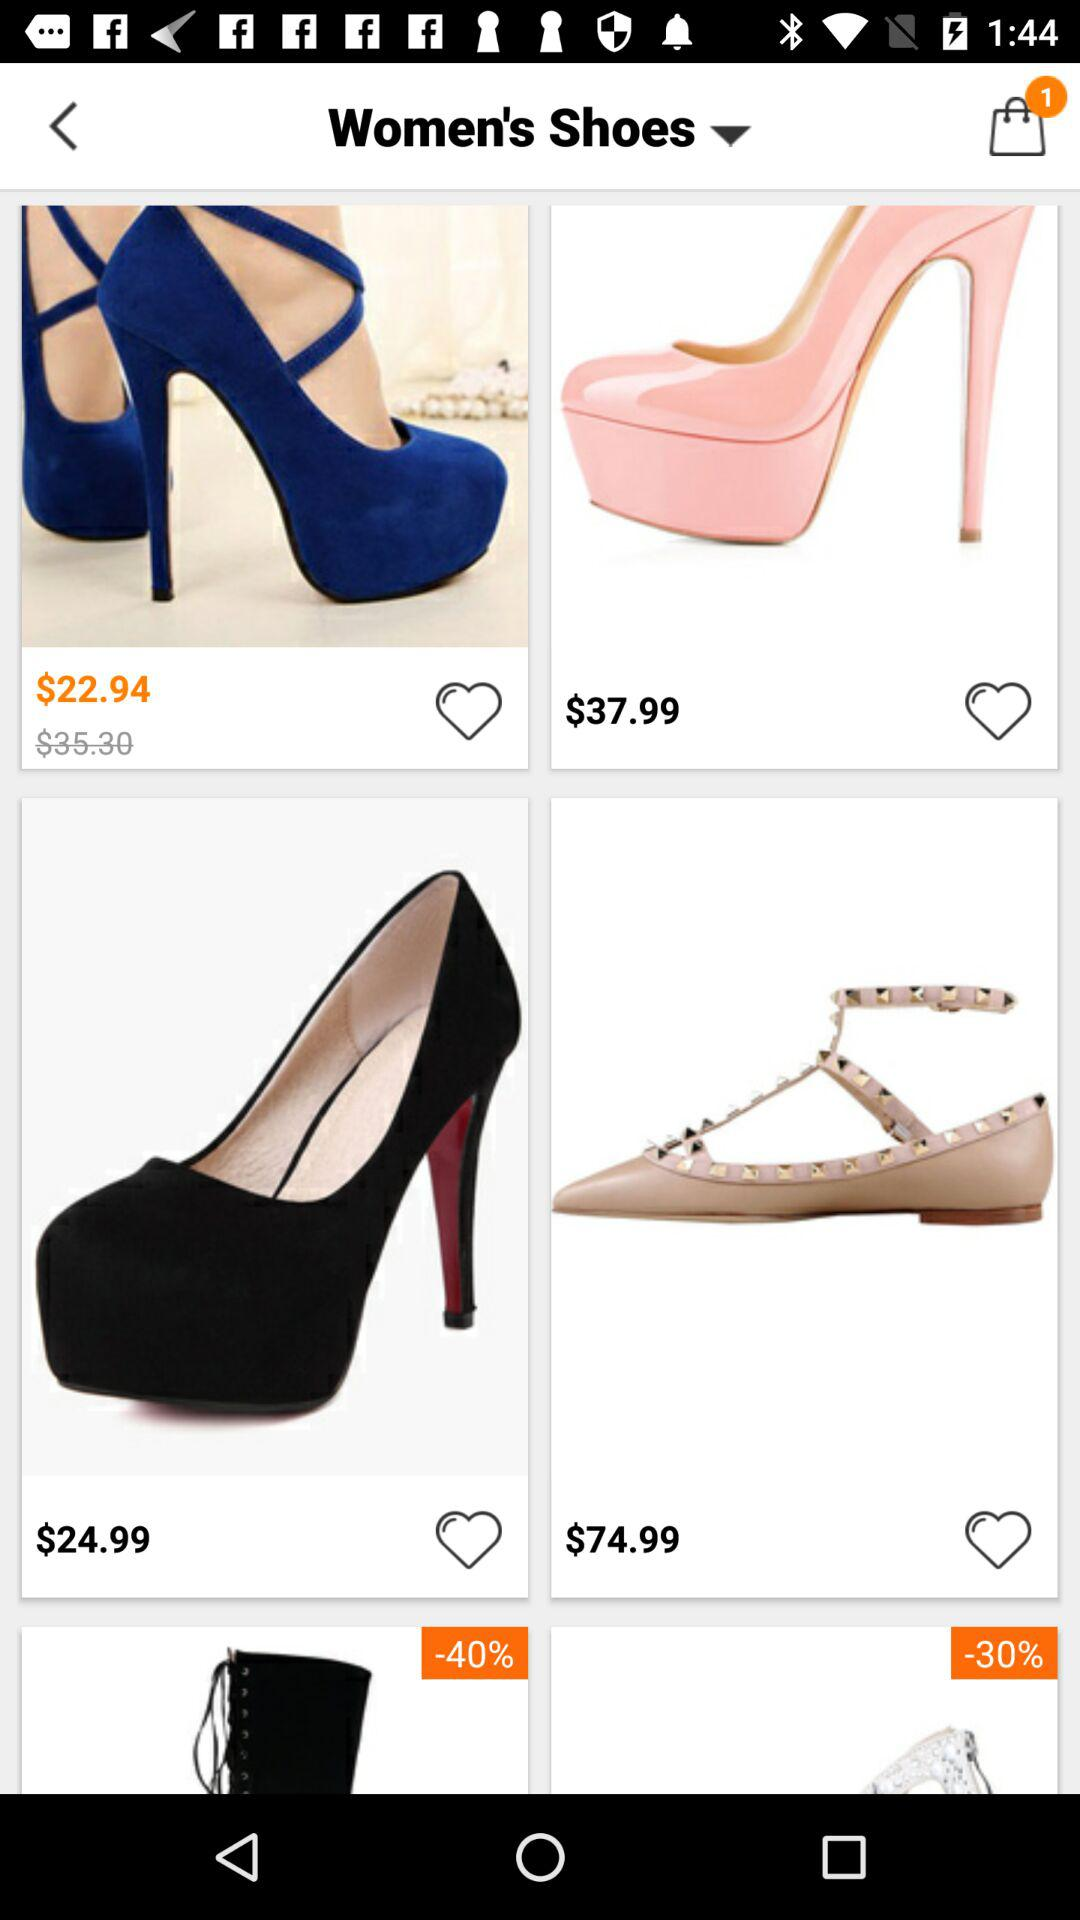How many items are in the shopping bag? There is 1 item in the shopping bag. 